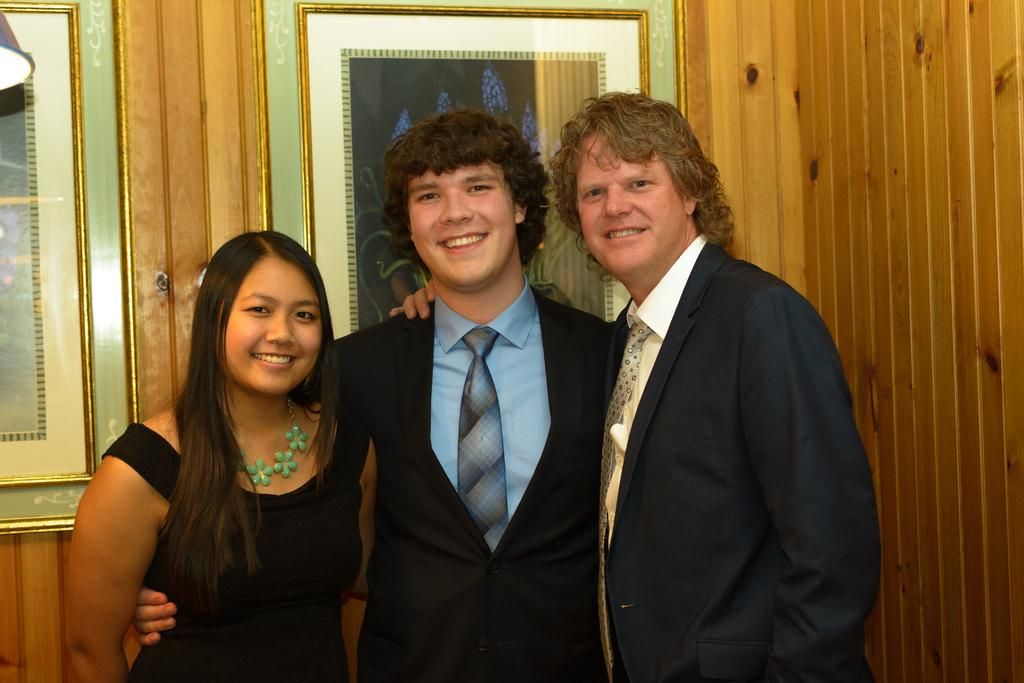How many people are in the image? There are three people in the image: one woman and two men. What are the people in the image doing? The woman and men are standing. What can be seen in the background of the image? There are frames on the wall in the background of the image. What is located in the left side top corner of the image? There is an object in the left side top corner of the image. What is the rate at which the woman's eye is blinking in the image? There is no information about the woman's eye or blinking rate in the image. 